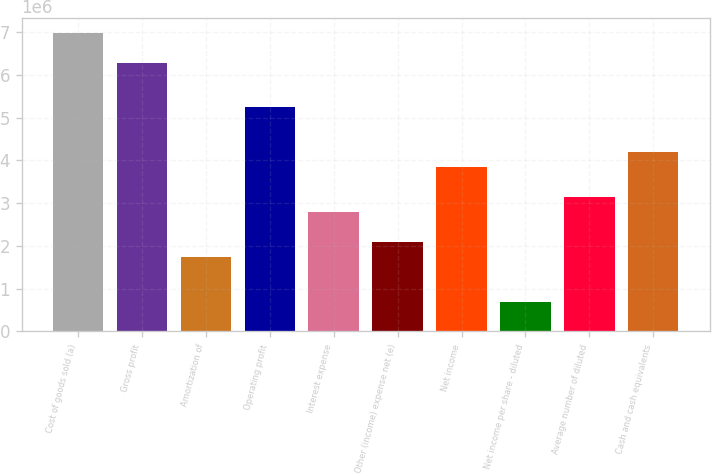<chart> <loc_0><loc_0><loc_500><loc_500><bar_chart><fcel>Cost of goods sold (a)<fcel>Gross profit<fcel>Amortization of<fcel>Operating profit<fcel>Interest expense<fcel>Other (income) expense net (e)<fcel>Net income<fcel>Net income per share - diluted<fcel>Average number of diluted<fcel>Cash and cash equivalents<nl><fcel>6.98924e+06<fcel>6.29032e+06<fcel>1.74731e+06<fcel>5.24193e+06<fcel>2.7957e+06<fcel>2.09677e+06<fcel>3.84408e+06<fcel>698926<fcel>3.14516e+06<fcel>4.19354e+06<nl></chart> 